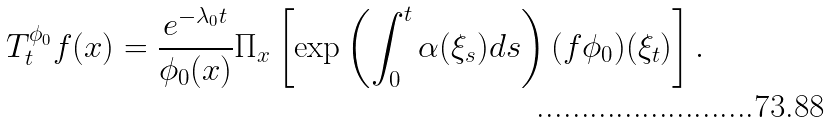<formula> <loc_0><loc_0><loc_500><loc_500>T ^ { \phi _ { 0 } } _ { t } f ( x ) = \frac { e ^ { - \lambda _ { 0 } t } } { \phi _ { 0 } ( x ) } \Pi _ { x } \left [ \exp \left ( \int ^ { t } _ { 0 } \alpha ( \xi _ { s } ) d s \right ) ( f \phi _ { 0 } ) ( \xi _ { t } ) \right ] .</formula> 